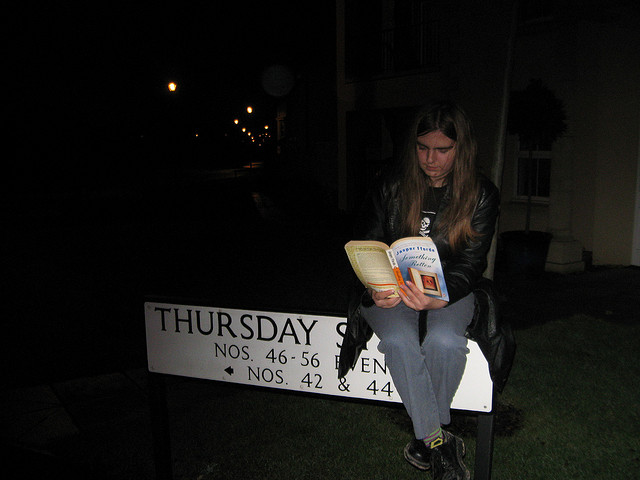Identify the text contained in this image. THURSDAY NOS 46.56 NOS 46 56 NOS. 44 & 42 